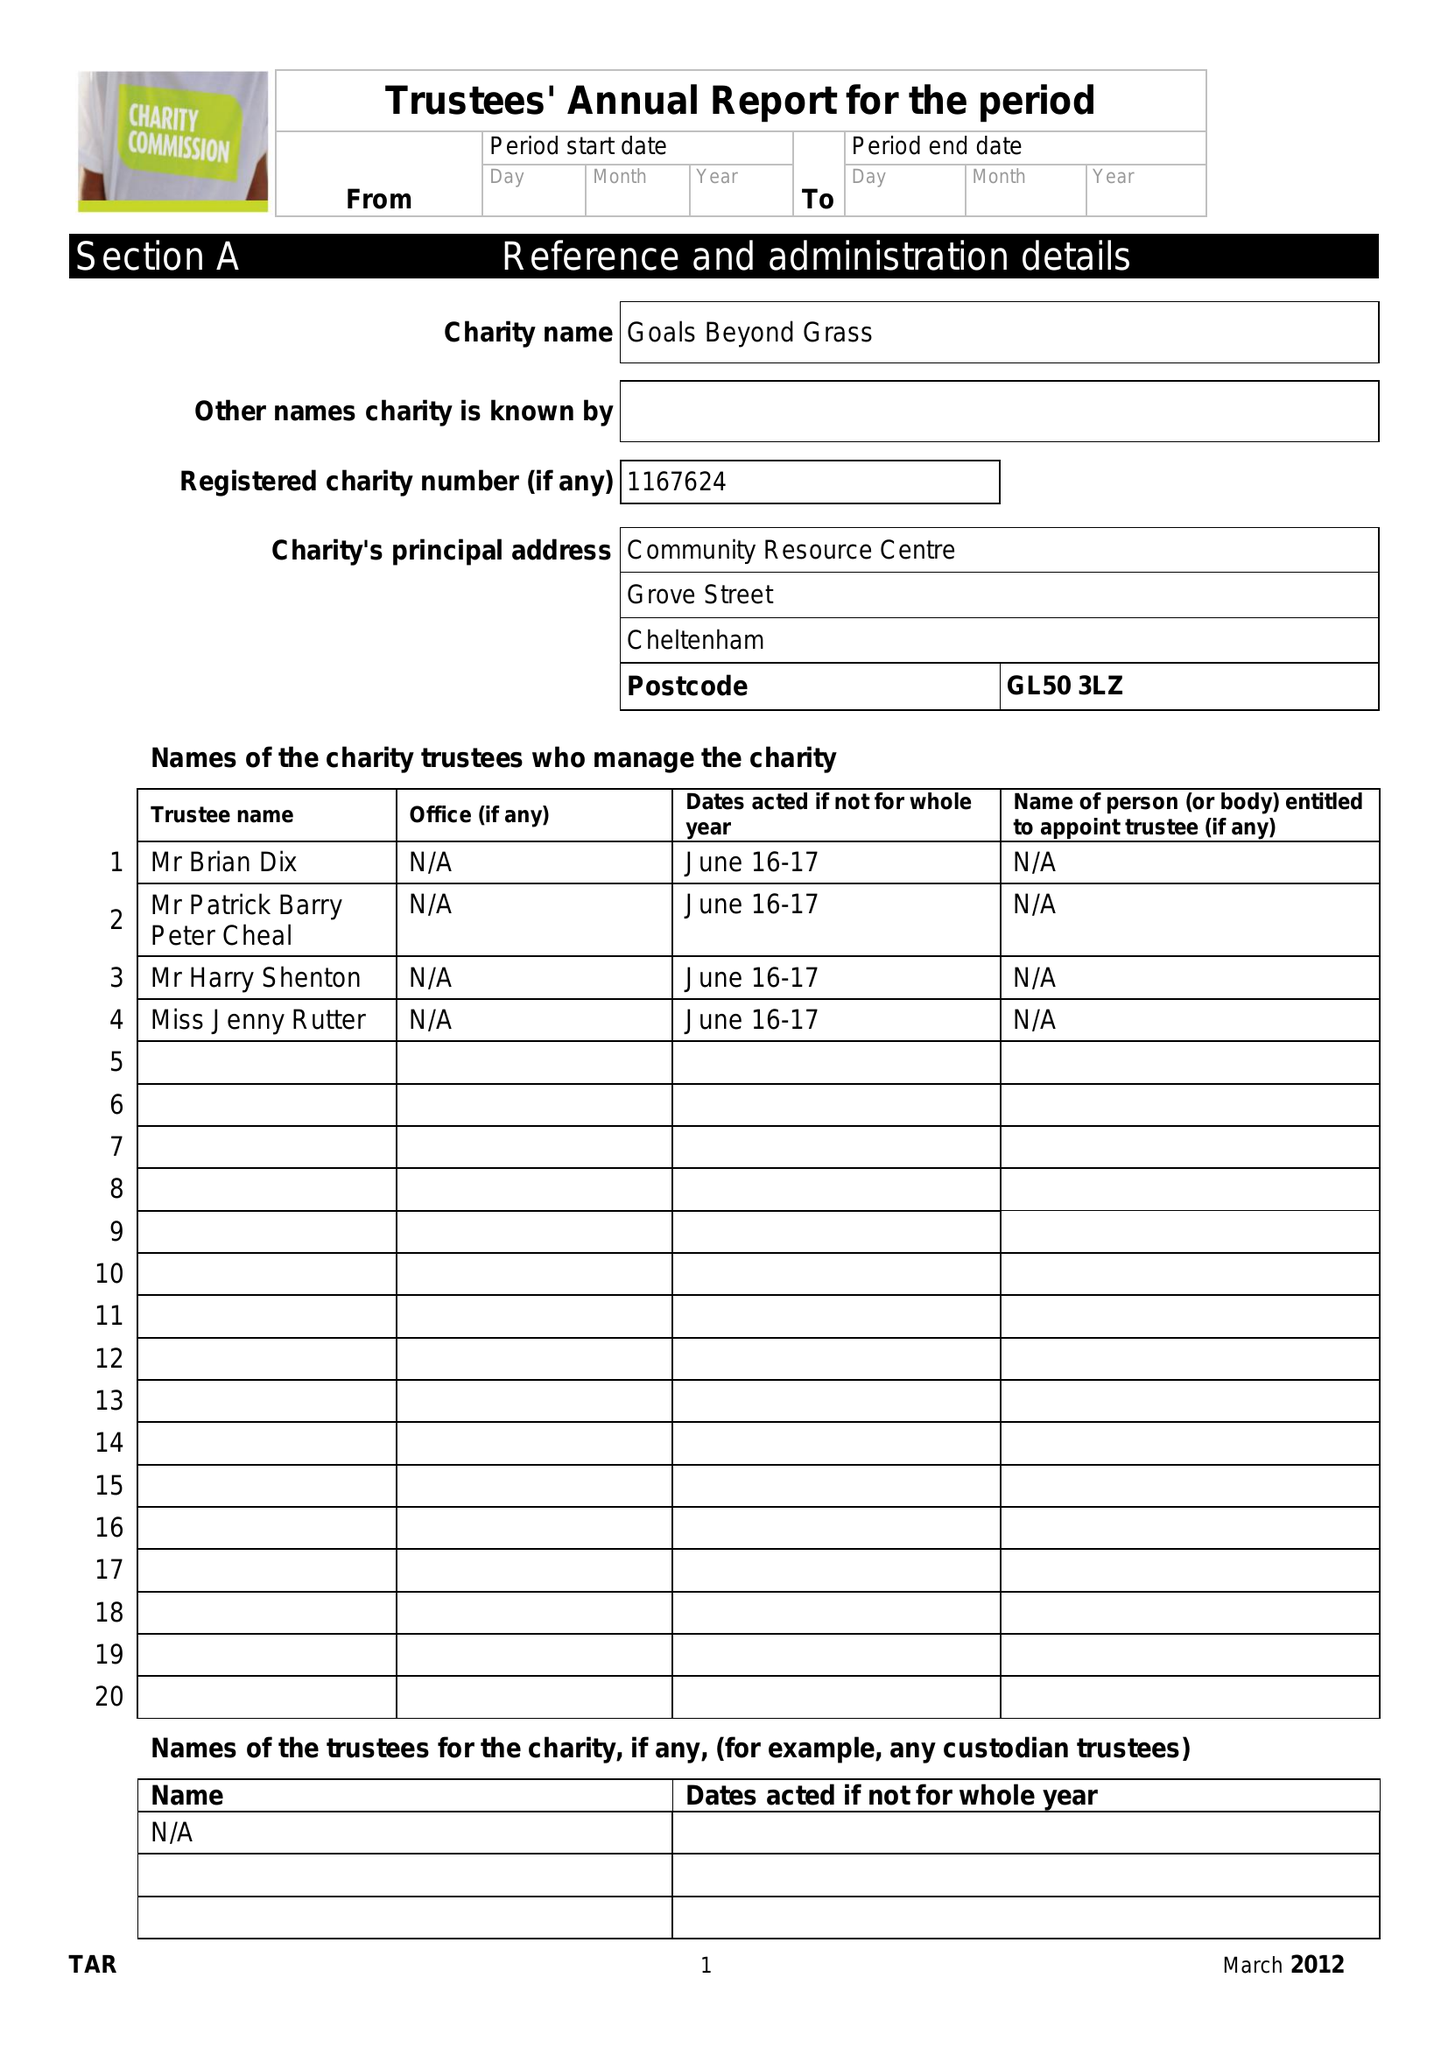What is the value for the charity_number?
Answer the question using a single word or phrase. 1167624 